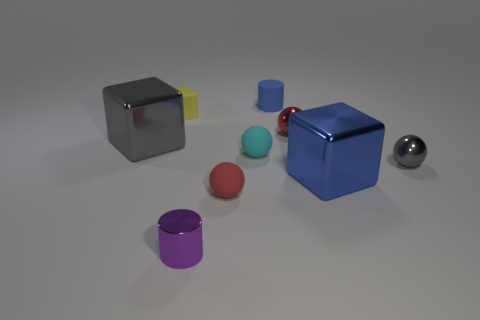Subtract 1 balls. How many balls are left? 3 Add 1 red rubber spheres. How many objects exist? 10 Subtract all blocks. How many objects are left? 6 Subtract 0 gray cylinders. How many objects are left? 9 Subtract all blue objects. Subtract all gray metallic blocks. How many objects are left? 6 Add 4 purple things. How many purple things are left? 5 Add 3 big shiny things. How many big shiny things exist? 5 